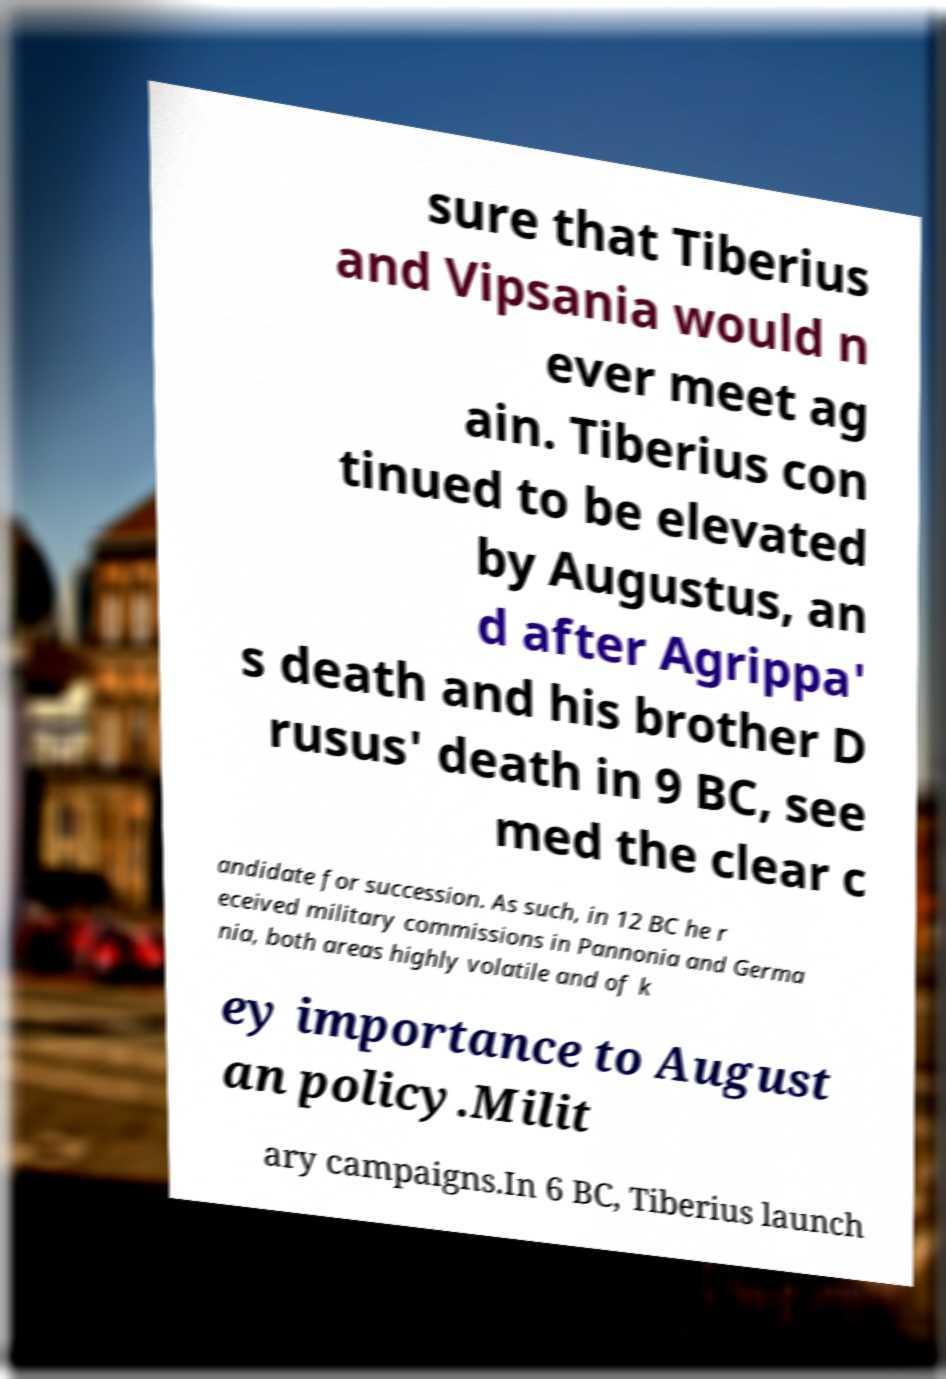I need the written content from this picture converted into text. Can you do that? sure that Tiberius and Vipsania would n ever meet ag ain. Tiberius con tinued to be elevated by Augustus, an d after Agrippa' s death and his brother D rusus' death in 9 BC, see med the clear c andidate for succession. As such, in 12 BC he r eceived military commissions in Pannonia and Germa nia, both areas highly volatile and of k ey importance to August an policy.Milit ary campaigns.In 6 BC, Tiberius launch 